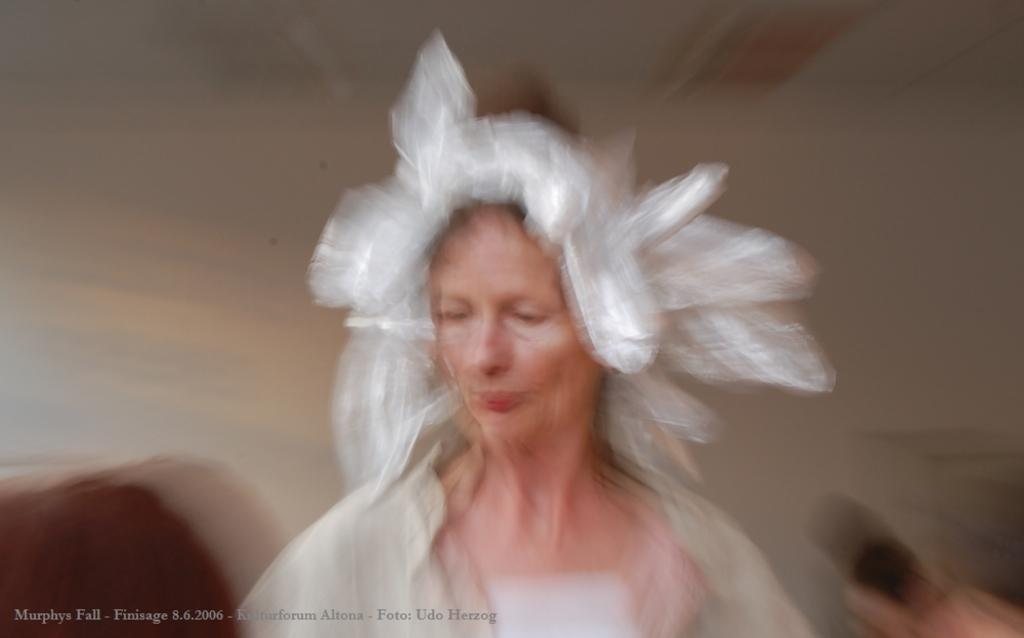Who is present in the image? There is a woman in the image. What is the woman wearing on her head? The woman is wearing a hat. What type of drink is the woman holding in the image? There is no drink visible in the image. 